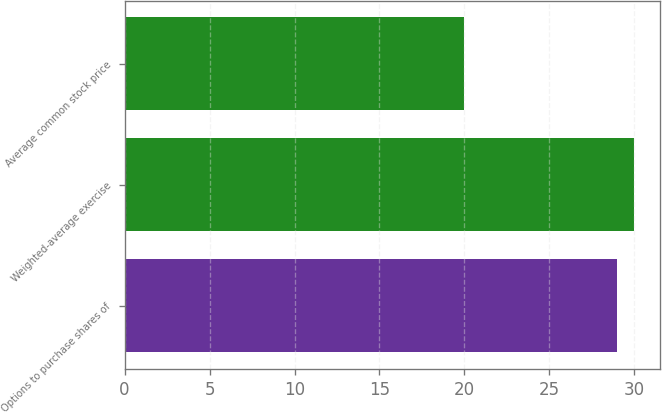Convert chart to OTSL. <chart><loc_0><loc_0><loc_500><loc_500><bar_chart><fcel>Options to purchase shares of<fcel>Weighted-average exercise<fcel>Average common stock price<nl><fcel>29<fcel>30<fcel>20<nl></chart> 